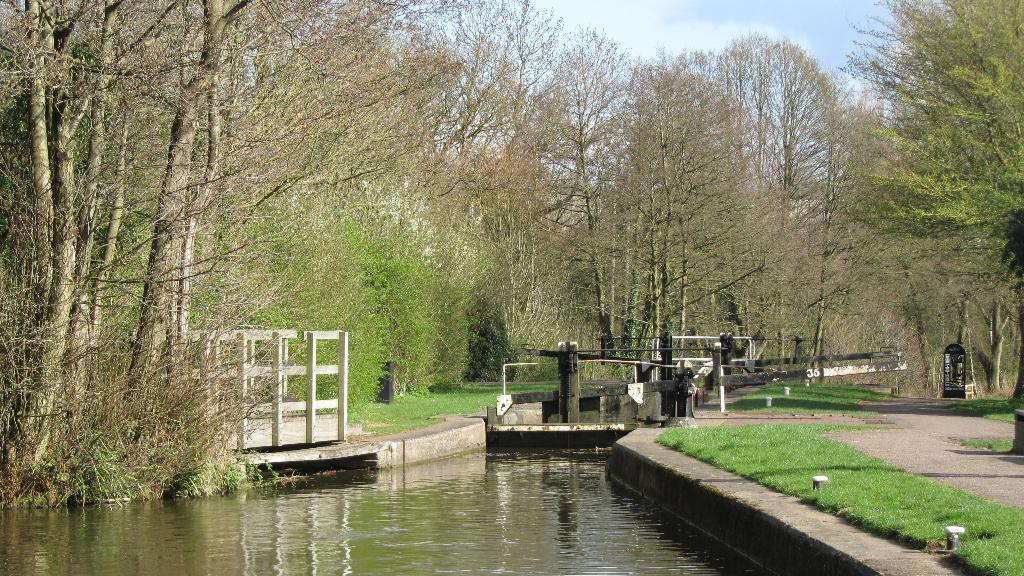Can you describe this image briefly? In the image in the center we can see water,trees,grass,poles,fence,swing and few other objects. In the background we can see the sky,clouds and trees. 